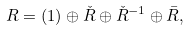<formula> <loc_0><loc_0><loc_500><loc_500>R = ( 1 ) \oplus \check { R } \oplus \check { R } ^ { - 1 } \oplus \bar { R } ,</formula> 